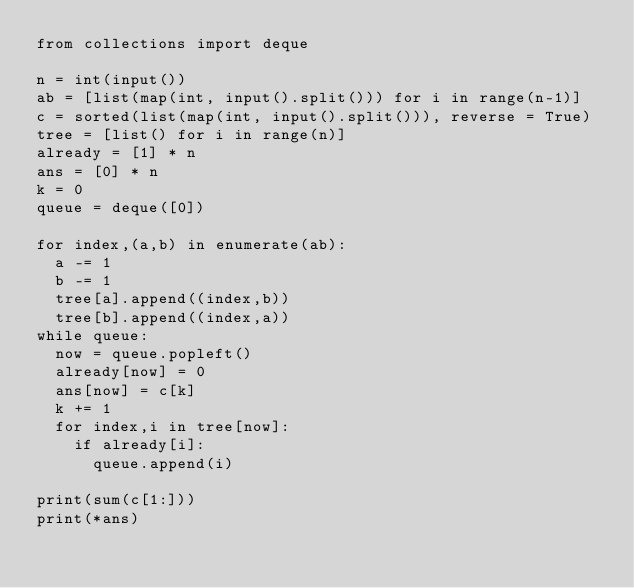Convert code to text. <code><loc_0><loc_0><loc_500><loc_500><_Python_>from collections import deque

n = int(input())
ab = [list(map(int, input().split())) for i in range(n-1)]
c = sorted(list(map(int, input().split())), reverse = True)
tree = [list() for i in range(n)]
already = [1] * n 
ans = [0] * n
k = 0
queue = deque([0])

for index,(a,b) in enumerate(ab):
  a -= 1
  b -= 1
  tree[a].append((index,b))
  tree[b].append((index,a))
while queue:
  now = queue.popleft()
  already[now] = 0
  ans[now] = c[k]
  k += 1
  for index,i in tree[now]:
    if already[i]:
      queue.append(i)
         
print(sum(c[1:]))
print(*ans)
</code> 